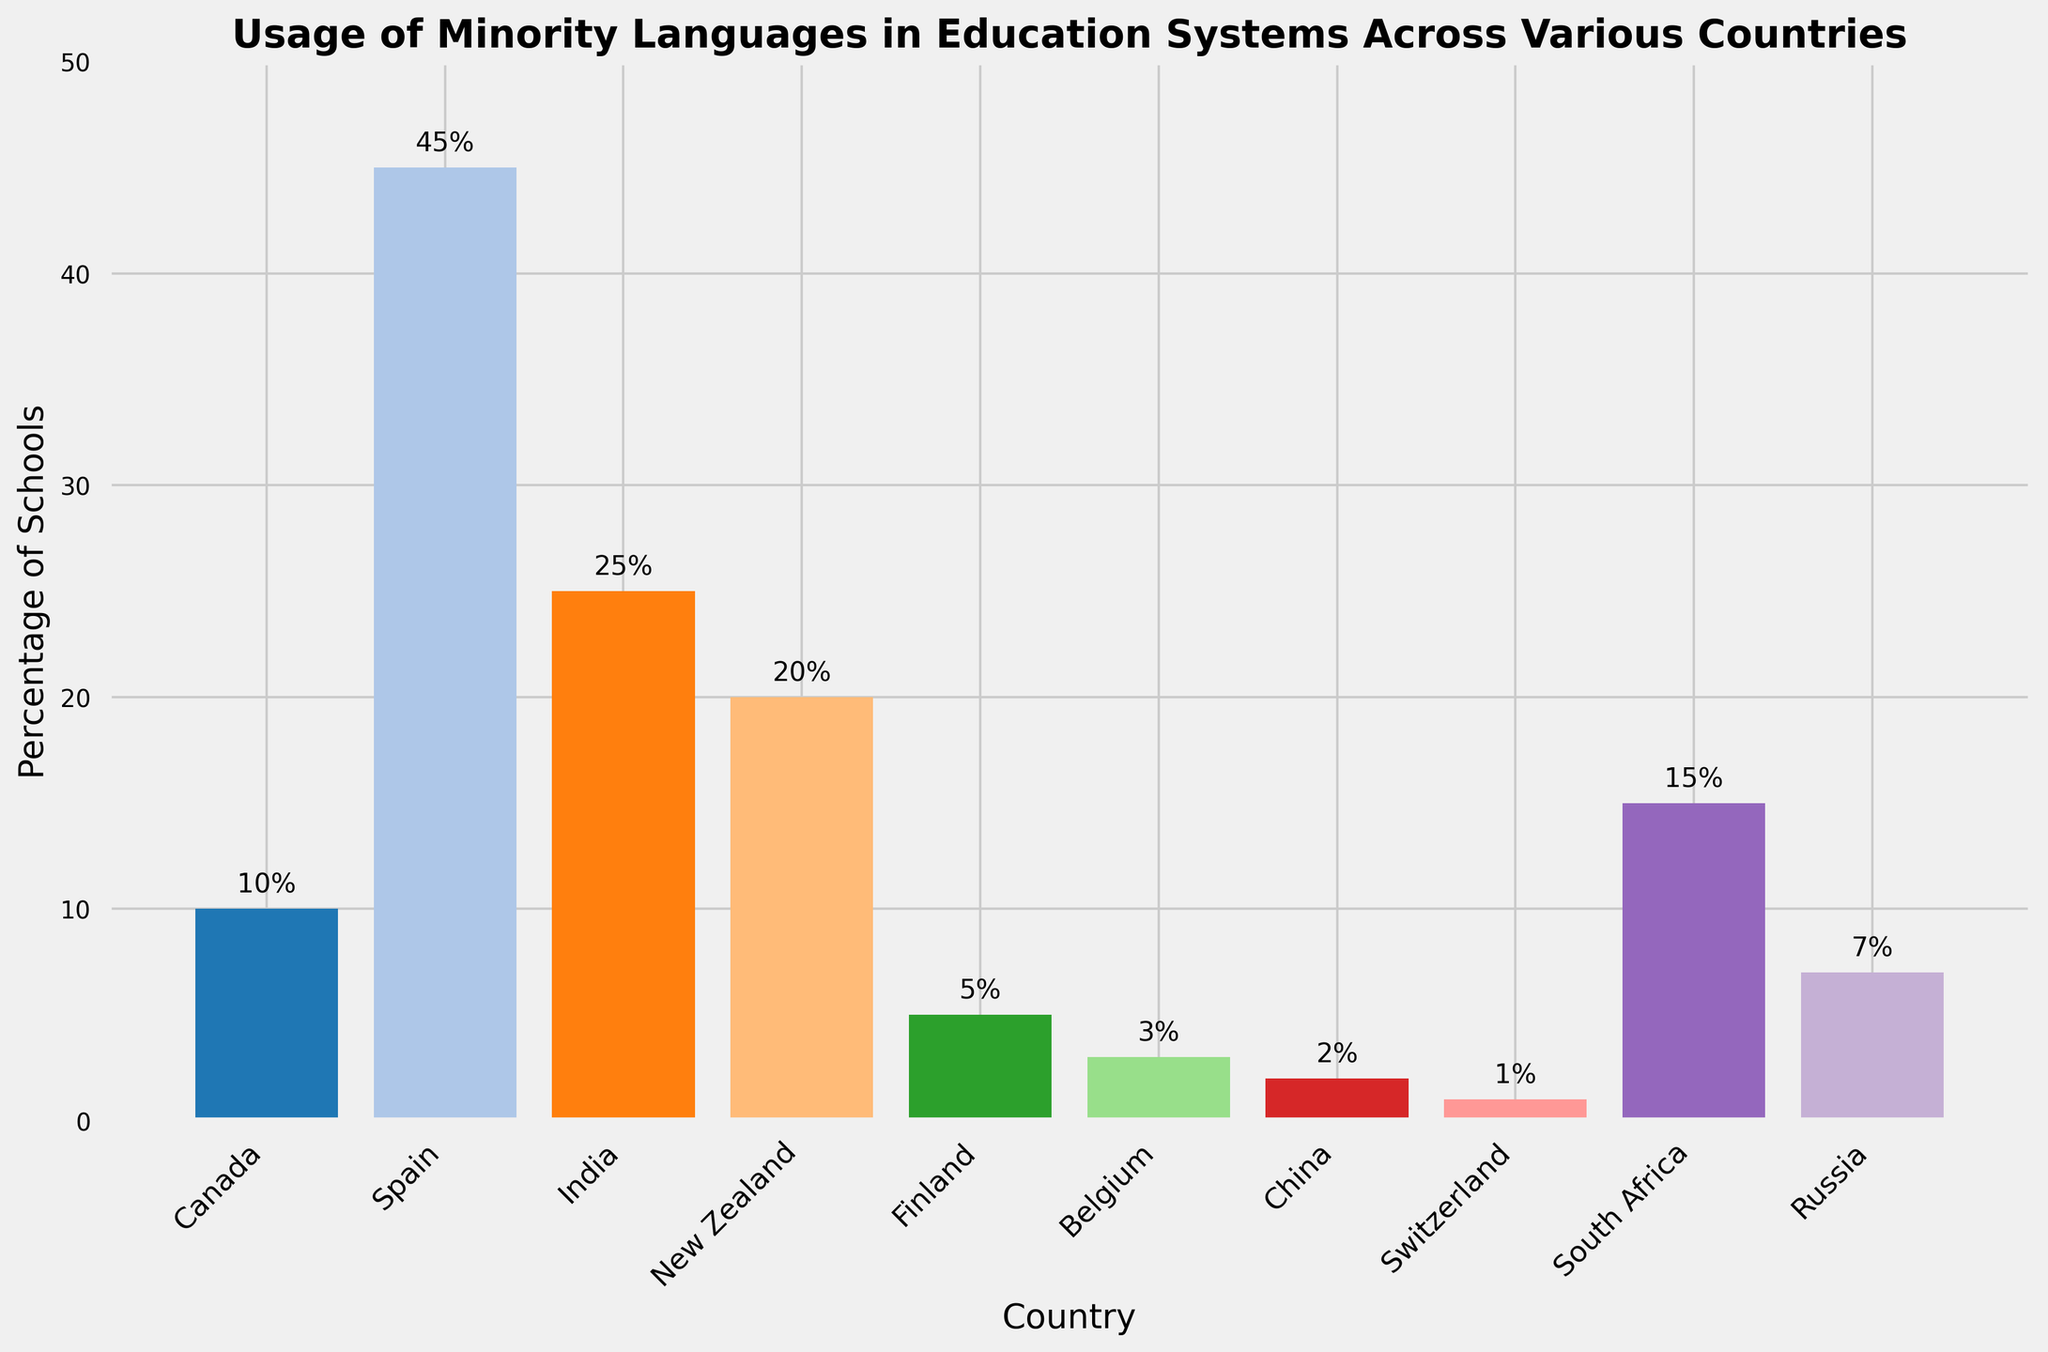What is the country with the highest usage of a minority language in its education system? The bar chart shows the percentage of schools using minority languages in various countries. By comparing the heights of the bars, Spain has the highest percentage of schools using a minority language (Catalan) with 45%.
Answer: Spain How many countries have at least 20% usage of a minority language in their education systems? Observing the bars that extend to or beyond the 20% mark, Spain (45%), India (25%), and New Zealand (20%) each have at least 20% of schools using a minority language. This totals to 3 countries.
Answer: 3 Which countries have a lower percentage of minority language usage in schools than Finland? Finland has a 5% usage rate. The countries with lower percentages are Belgium (3%), China (2%), and Switzerland (1%).
Answer: Belgium, China, Switzerland What is the average percentage of schools using minority languages in education systems across all the listed countries? Summing all percentages: 10 + 45 + 25 + 20 + 5 + 3 + 2 + 1 + 15 + 7 = 133. Dividing by the number of countries (10), the average is 133 / 10 = 13.3%.
Answer: 13.3% Which country uses the minority language, Xhosa, and what is the percentage usage in that country? From the bar chart, South Africa uses the minority language Xhosa, with a 15% usage rate in its education system.
Answer: South Africa, 15% What is the difference between the percentage of schools using minority languages in India and Finland? The bar for India shows 25%, and Finland shows 5%. The difference is 25 - 5 = 20%.
Answer: 20% Which countries are represented by bars taller than 10% but shorter than 20% in height? Bars representing India (25%) and New Zealand (20%) exceed 10%, therefore, the ones between 10% and 20% inclusive are Canada (10%), New Zealand (20%) and South Africa (15%).
Answer: Canada, New Zealand, South Africa Among the countries listed, which has the smallest percentage of schools using a minority language, and what is that percentage? The smallest percentage is represented by the shortest bar, which belongs to Switzerland, with 1%.
Answer: Switzerland, 1% What is the combined percentage of schools using minority languages in China and Belgium? China's percentage is 2% and Belgium's is 3%. Adding them together, 2 + 3 = 5%.
Answer: 5% 